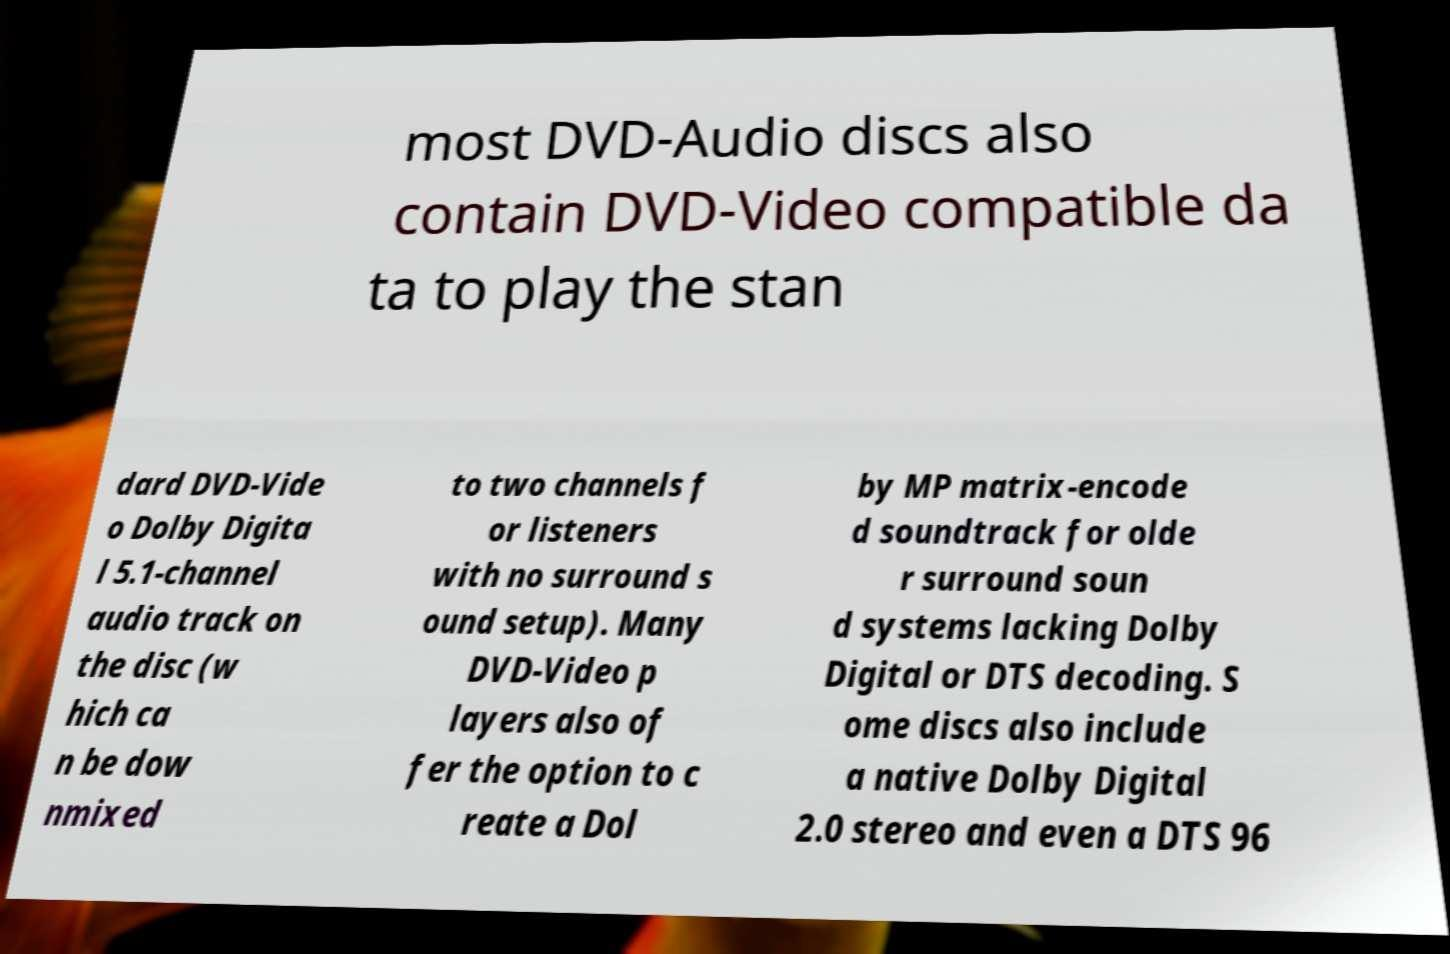I need the written content from this picture converted into text. Can you do that? most DVD-Audio discs also contain DVD-Video compatible da ta to play the stan dard DVD-Vide o Dolby Digita l 5.1-channel audio track on the disc (w hich ca n be dow nmixed to two channels f or listeners with no surround s ound setup). Many DVD-Video p layers also of fer the option to c reate a Dol by MP matrix-encode d soundtrack for olde r surround soun d systems lacking Dolby Digital or DTS decoding. S ome discs also include a native Dolby Digital 2.0 stereo and even a DTS 96 